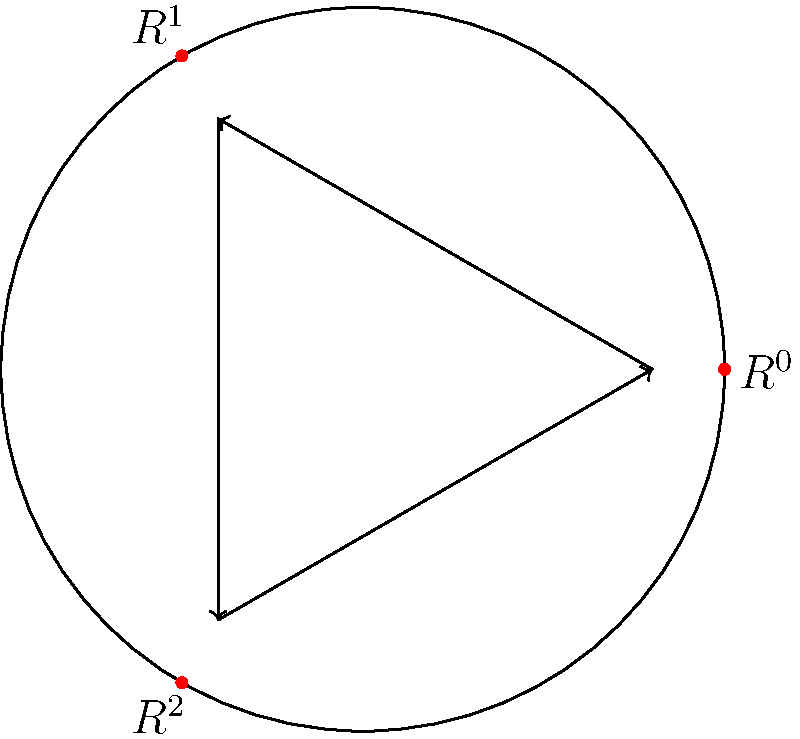In a military hospital, the shift rotation system for medical staff follows a cyclic group structure. The diagram represents the rotation system with three shifts: Day (D), Evening (E), and Night (N). If $R$ represents a single rotation, what is the order of the group generated by $R$, and what is $R^{-1}$ in terms of $R$? To solve this problem, let's follow these steps:

1) First, we need to understand what the diagram represents:
   - $R^0$ represents no rotation (identity element)
   - $R^1$ represents one rotation (e.g., D → E → N → D)
   - $R^2$ represents two rotations (e.g., D → N → E → D)

2) To find the order of the group:
   - We see that after three rotations, we return to the starting position
   - This means $R^3 = R^0$ (the identity element)
   - Therefore, the order of the group is 3

3) To find $R^{-1}$ in terms of $R$:
   - In a cyclic group, the inverse of an element is the element that, when combined with the original element, gives the identity
   - We know that $R \cdot R^2 = R^3 = R^0$ (the identity)
   - This means $R^2$ is the inverse of $R$

4) Therefore, $R^{-1} = R^2$

This cyclic group of order 3 is isomorphic to the group $\mathbb{Z}_3$ under addition modulo 3.
Answer: Order: 3, $R^{-1} = R^2$ 